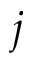<formula> <loc_0><loc_0><loc_500><loc_500>j</formula> 